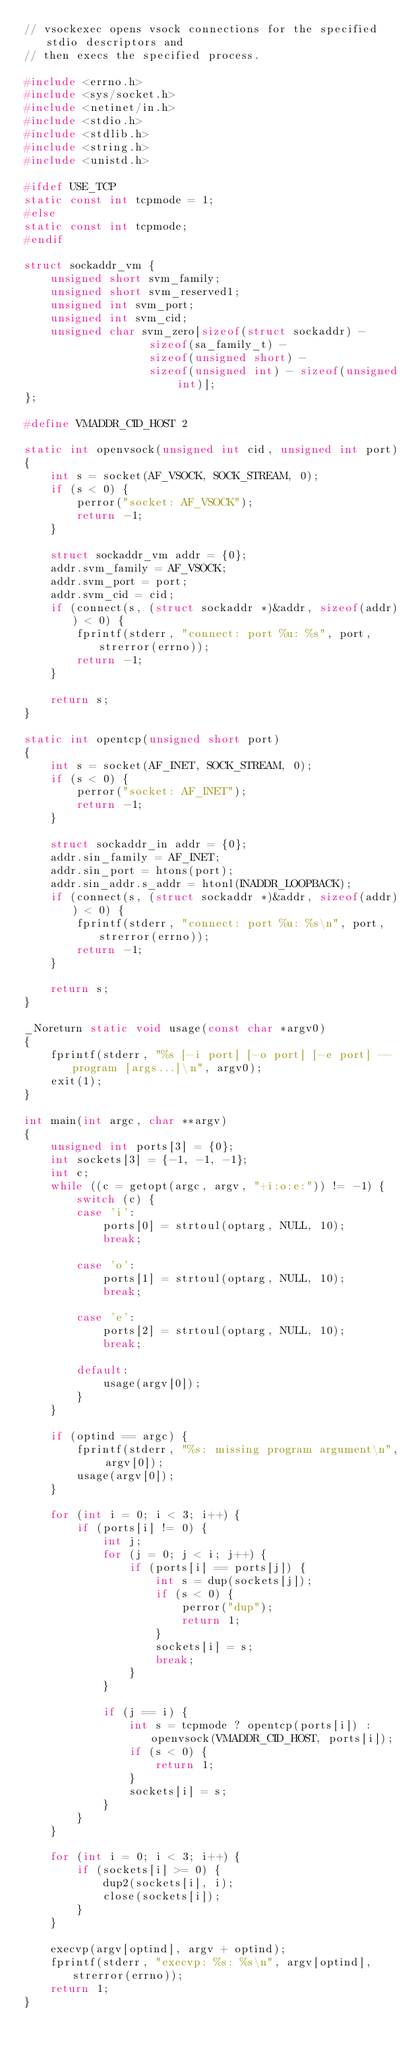Convert code to text. <code><loc_0><loc_0><loc_500><loc_500><_C_>// vsockexec opens vsock connections for the specified stdio descriptors and
// then execs the specified process.

#include <errno.h>
#include <sys/socket.h>
#include <netinet/in.h>
#include <stdio.h>
#include <stdlib.h>
#include <string.h>
#include <unistd.h>

#ifdef USE_TCP
static const int tcpmode = 1;
#else
static const int tcpmode;
#endif

struct sockaddr_vm {
	unsigned short svm_family;
	unsigned short svm_reserved1;
	unsigned int svm_port;
	unsigned int svm_cid;
	unsigned char svm_zero[sizeof(struct sockaddr) -
			       sizeof(sa_family_t) -
			       sizeof(unsigned short) -
			       sizeof(unsigned int) - sizeof(unsigned int)];
};

#define VMADDR_CID_HOST 2

static int openvsock(unsigned int cid, unsigned int port)
{
    int s = socket(AF_VSOCK, SOCK_STREAM, 0);
    if (s < 0) {
        perror("socket: AF_VSOCK");
        return -1;
    }

    struct sockaddr_vm addr = {0};
    addr.svm_family = AF_VSOCK;
    addr.svm_port = port;
    addr.svm_cid = cid;
    if (connect(s, (struct sockaddr *)&addr, sizeof(addr)) < 0) {
        fprintf(stderr, "connect: port %u: %s", port, strerror(errno));
        return -1;
    }

    return s;
}

static int opentcp(unsigned short port)
{
    int s = socket(AF_INET, SOCK_STREAM, 0);
    if (s < 0) {
        perror("socket: AF_INET");
        return -1;
    }

    struct sockaddr_in addr = {0};
    addr.sin_family = AF_INET;
    addr.sin_port = htons(port);
    addr.sin_addr.s_addr = htonl(INADDR_LOOPBACK);
    if (connect(s, (struct sockaddr *)&addr, sizeof(addr)) < 0) {
        fprintf(stderr, "connect: port %u: %s\n", port, strerror(errno));
        return -1;
    }

    return s;
}

_Noreturn static void usage(const char *argv0)
{
    fprintf(stderr, "%s [-i port] [-o port] [-e port] -- program [args...]\n", argv0);
    exit(1);
}

int main(int argc, char **argv)
{
    unsigned int ports[3] = {0};
    int sockets[3] = {-1, -1, -1};
    int c;
    while ((c = getopt(argc, argv, "+i:o:e:")) != -1) {
        switch (c) {
        case 'i':
            ports[0] = strtoul(optarg, NULL, 10);
            break;

        case 'o':
            ports[1] = strtoul(optarg, NULL, 10);
            break;

        case 'e':
            ports[2] = strtoul(optarg, NULL, 10);
            break;

        default:
            usage(argv[0]);
        }
    }

    if (optind == argc) {
        fprintf(stderr, "%s: missing program argument\n", argv[0]);
        usage(argv[0]);
    }

    for (int i = 0; i < 3; i++) {
        if (ports[i] != 0) {
            int j;
            for (j = 0; j < i; j++) {
                if (ports[i] == ports[j]) {
                    int s = dup(sockets[j]);
                    if (s < 0) {
                        perror("dup");
                        return 1;
                    }
                    sockets[i] = s;
                    break;
                }
            }

            if (j == i) {
                int s = tcpmode ? opentcp(ports[i]) : openvsock(VMADDR_CID_HOST, ports[i]);
                if (s < 0) {
                    return 1;
                }
                sockets[i] = s;
            }
        }
    }

    for (int i = 0; i < 3; i++) {
        if (sockets[i] >= 0) {
            dup2(sockets[i], i);
            close(sockets[i]);
        }
    }

    execvp(argv[optind], argv + optind);
    fprintf(stderr, "execvp: %s: %s\n", argv[optind], strerror(errno));
    return 1;
}
</code> 